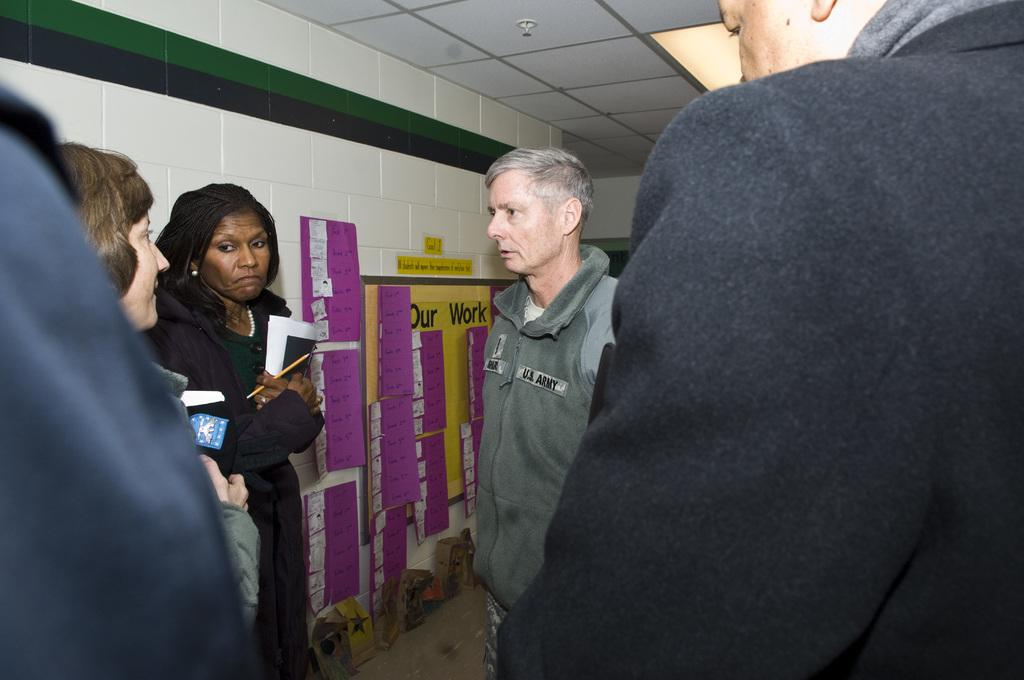What can be seen in the foreground of the image? There are people standing in the foreground of the image. What are some of the people holding in their hands? Some people are holding books in their hands. What can be seen on the walls or surfaces in the image? There are posters visible in the image. What other objects can be seen in the image besides the people and posters? Other objects are present in the image. What is located on the roof in the background of the image? There is a lamp on the roof in the background. What type of account is being discussed by the people in the image? There is no indication in the image that the people are discussing any type of account. 